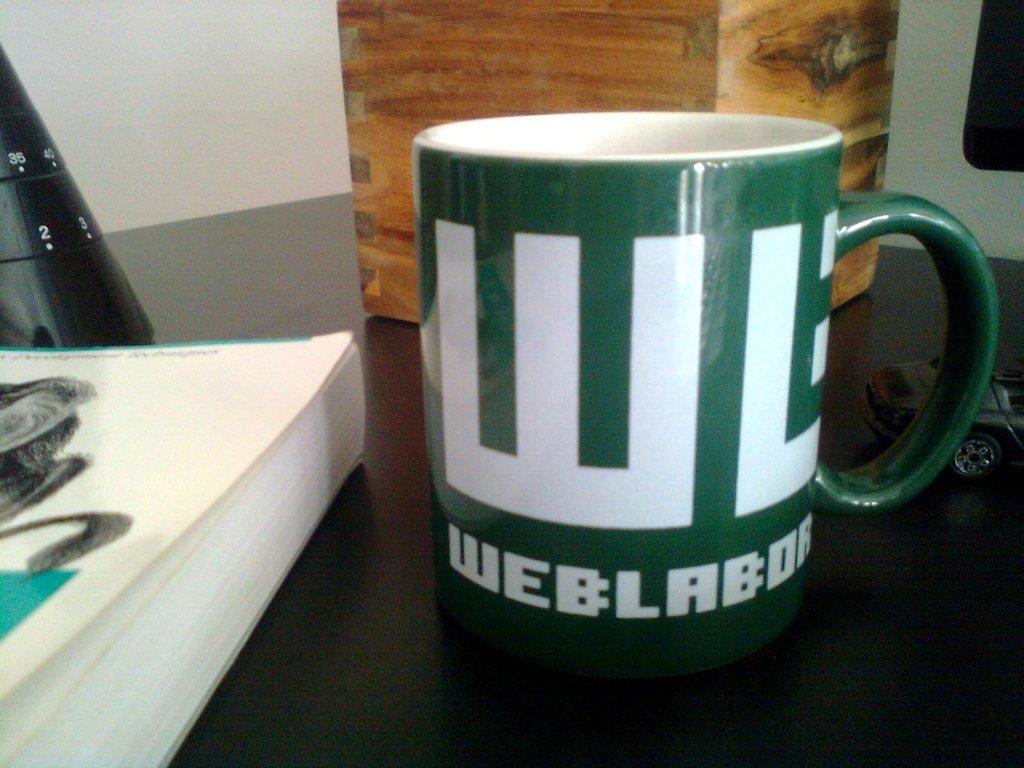What does wl stand for?
Your answer should be very brief. Web lab. What is the word under the two letters wl?
Provide a short and direct response. Weblabor. 